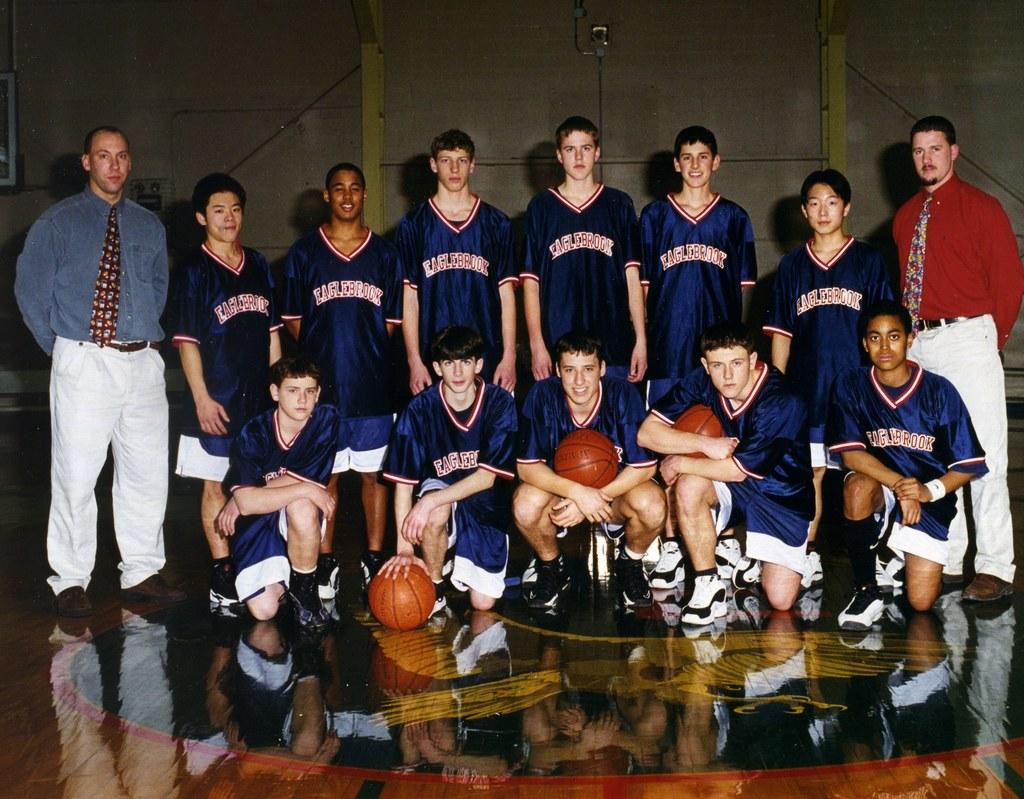What is the team name?
Your response must be concise. Eaglebrook. 